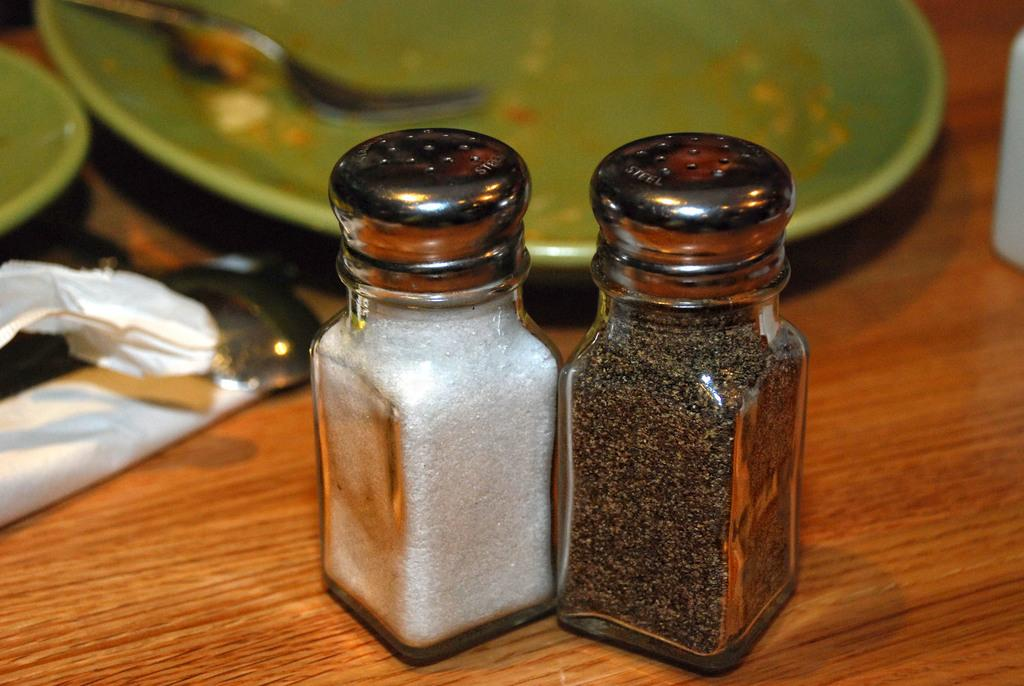What type of objects can be seen on the table in the image? There are plates, jars, and forks on the table in the image. What might these objects be used for? The plates, jars, and forks are likely used for serving and eating food. Can you describe the arrangement of these objects on the table? Unfortunately, the arrangement of these objects cannot be determined from the provided facts. What type of suit is the person wearing in the image? There is no mention of a person or a suit in the provided facts. 